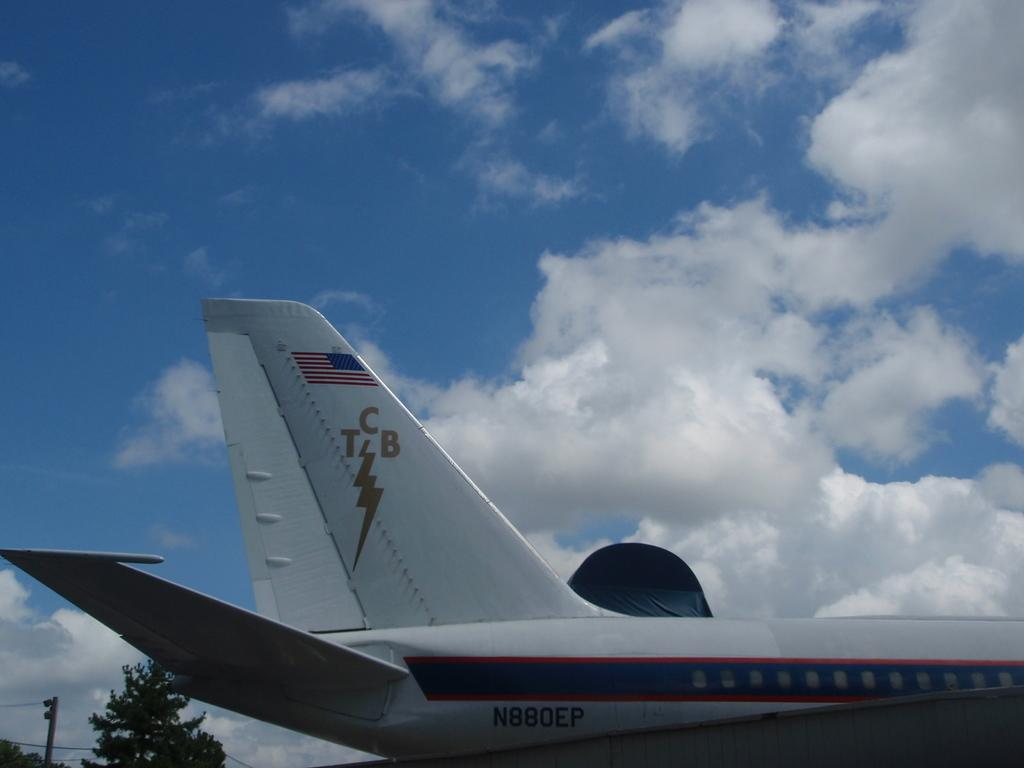What is the main subject in the image? There is an aeroplane on the road in the image. What can be seen at the back side of the image? There are trees and a utility pole at the back side of the image. What is visible in the background of the image? The sky is visible in the background of the image. What type of thought is the doctor having about the relation in the image? There is no doctor or relation present in the image, so it is not possible to determine any thoughts they might have. 